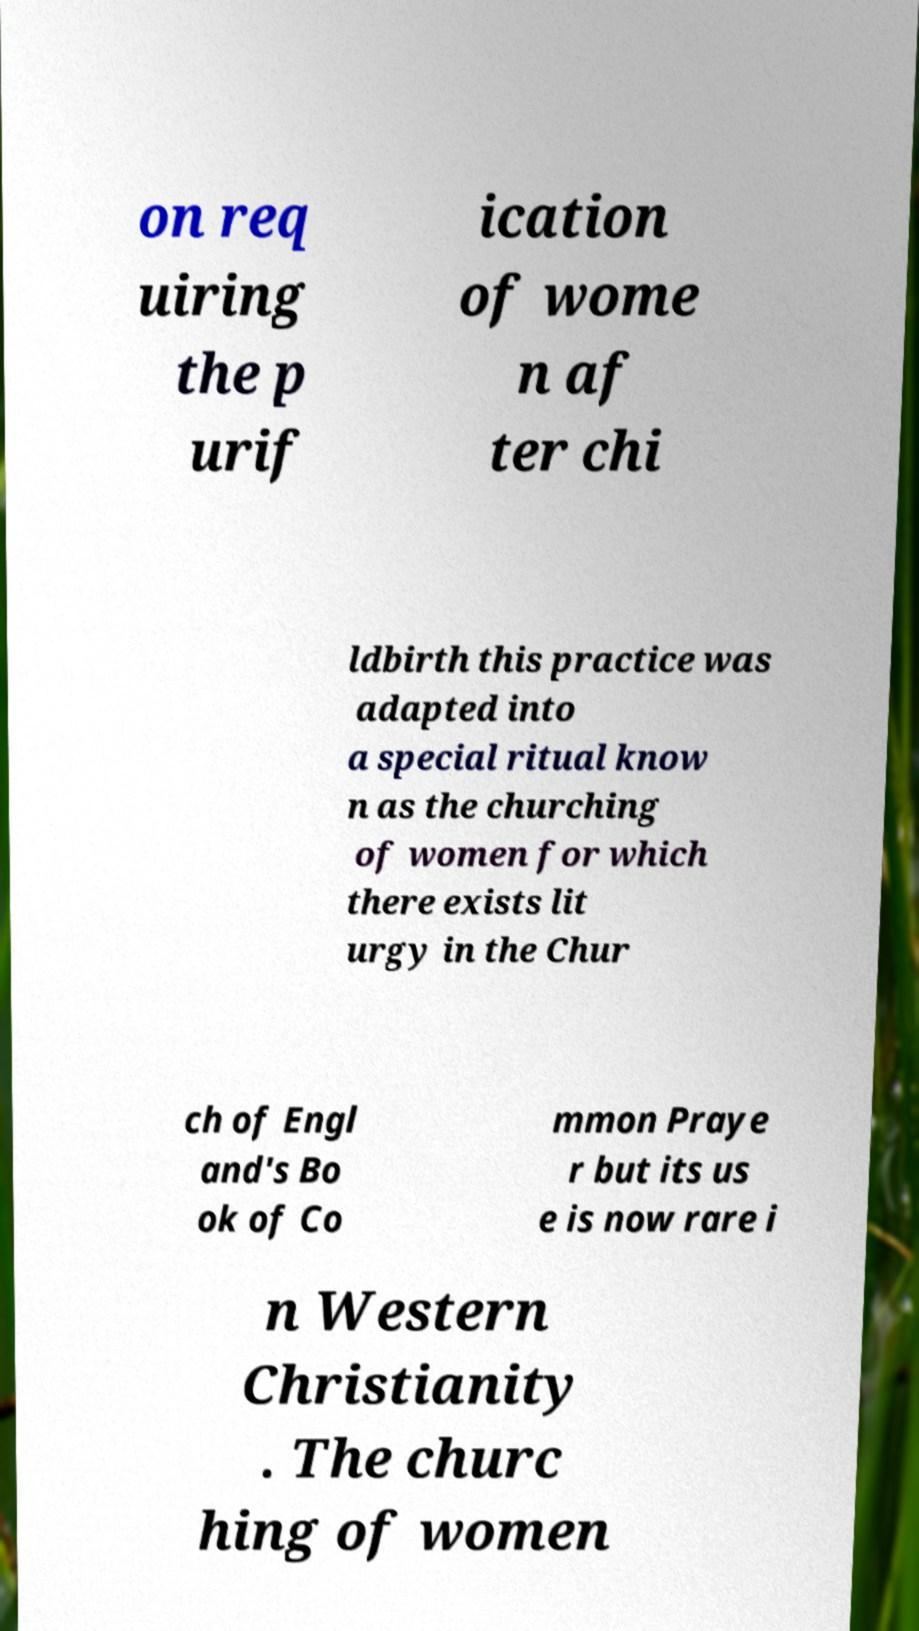Can you accurately transcribe the text from the provided image for me? on req uiring the p urif ication of wome n af ter chi ldbirth this practice was adapted into a special ritual know n as the churching of women for which there exists lit urgy in the Chur ch of Engl and's Bo ok of Co mmon Praye r but its us e is now rare i n Western Christianity . The churc hing of women 